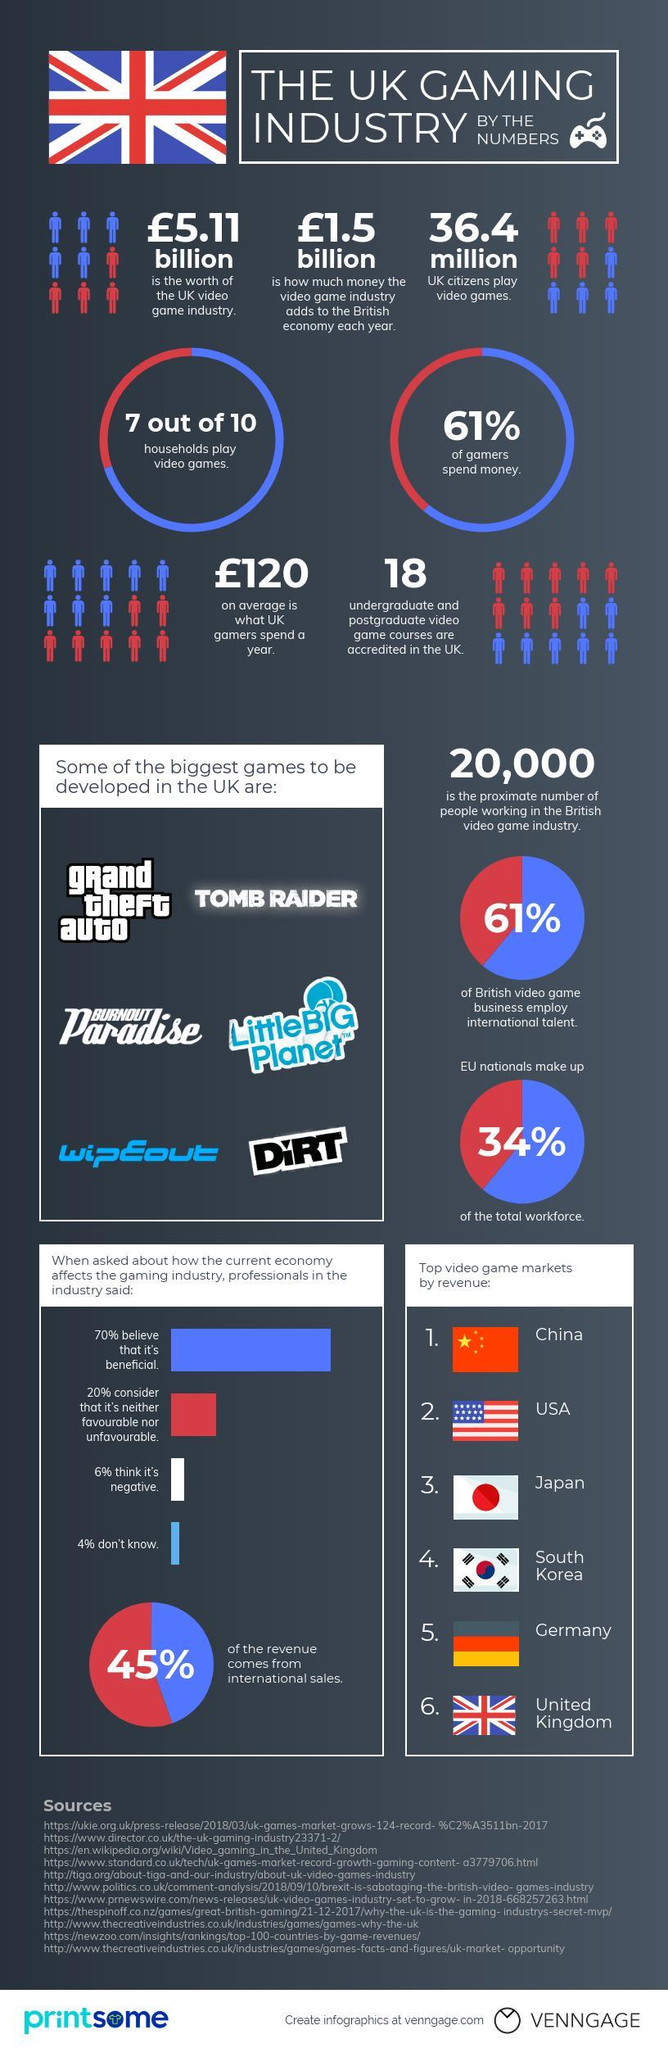What is the worth of UK video game industry in pounds?
Answer the question with a short phrase. 5.11 billion How many undergraduate & post graduate game courses are accredited in the UK? 18 Which country has the highest video game revenue? China What population of UK citizens play video games? 36.4 million 